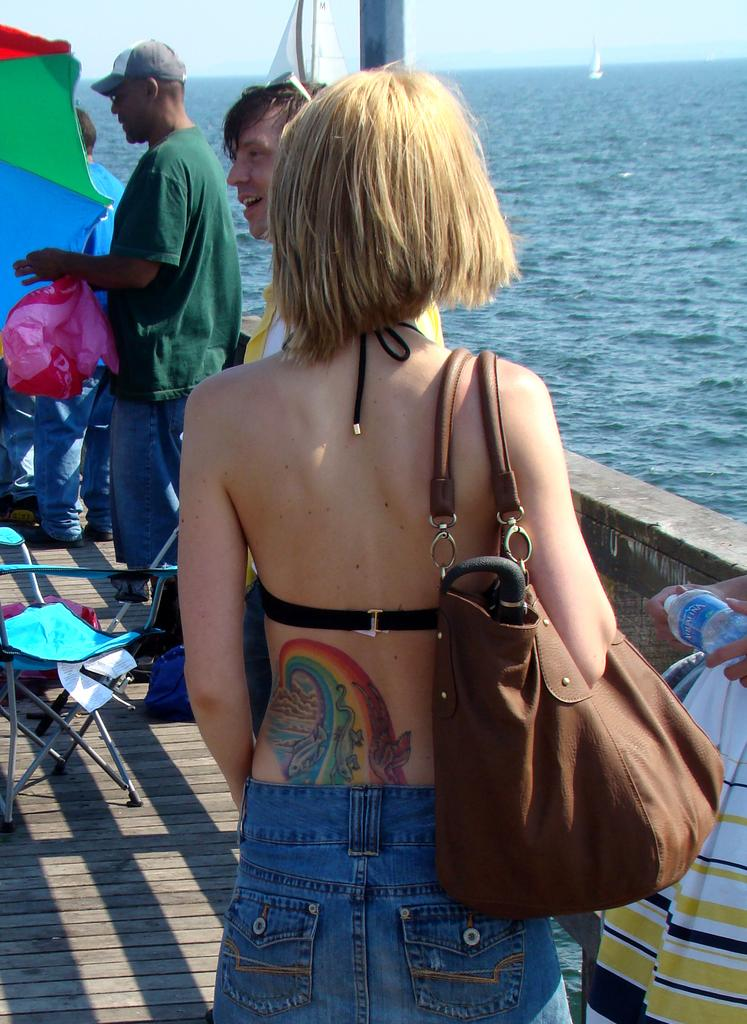How many people are in the image? There is a group of persons in the image. Where are the persons located in the image? The persons are standing on a boat. What can be seen at the right side of the image? There is water visible at the right side of the image. What type of park can be seen in the image? There is no park present in the image; it features a group of persons standing on a boat with water visible at the right side. 